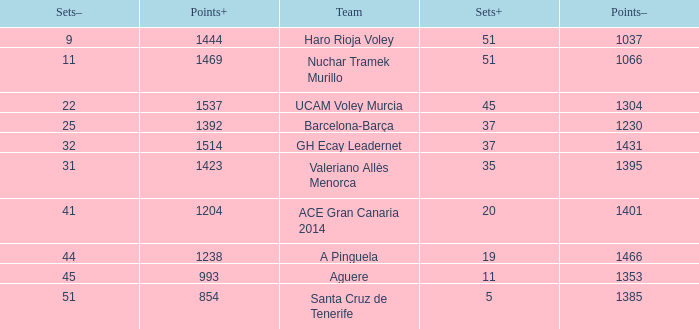Who is the team who had a Sets+ number smaller than 20, a Sets- number of 45, and a Points+ number smaller than 1238? Aguere. 